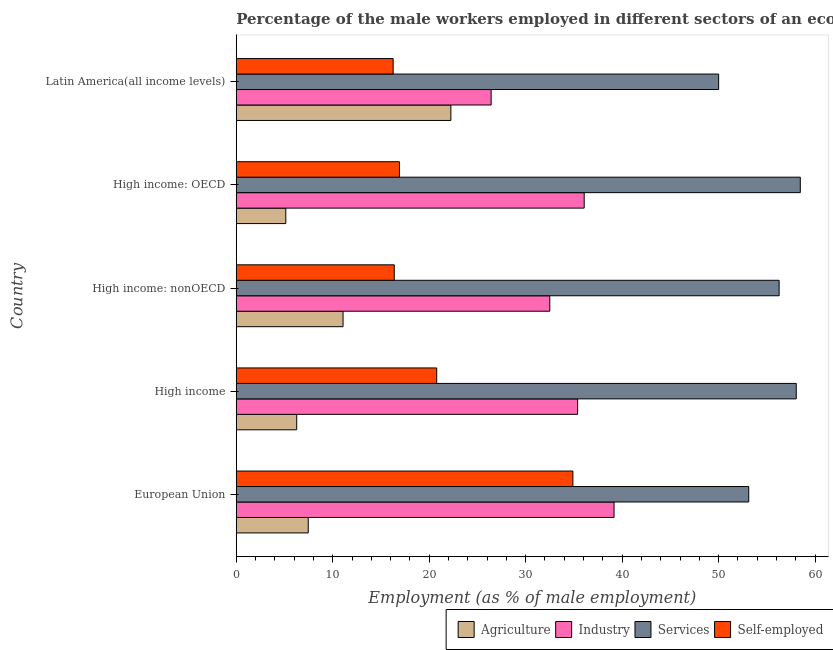How many different coloured bars are there?
Provide a succinct answer. 4. How many groups of bars are there?
Your response must be concise. 5. How many bars are there on the 1st tick from the top?
Provide a short and direct response. 4. How many bars are there on the 5th tick from the bottom?
Provide a succinct answer. 4. What is the label of the 5th group of bars from the top?
Provide a short and direct response. European Union. In how many cases, is the number of bars for a given country not equal to the number of legend labels?
Your answer should be compact. 0. What is the percentage of self employed male workers in European Union?
Provide a succinct answer. 34.89. Across all countries, what is the maximum percentage of self employed male workers?
Your answer should be very brief. 34.89. Across all countries, what is the minimum percentage of self employed male workers?
Provide a short and direct response. 16.26. In which country was the percentage of male workers in industry maximum?
Ensure brevity in your answer.  European Union. In which country was the percentage of male workers in agriculture minimum?
Your answer should be very brief. High income: OECD. What is the total percentage of self employed male workers in the graph?
Ensure brevity in your answer.  105.23. What is the difference between the percentage of self employed male workers in High income and that in High income: nonOECD?
Keep it short and to the point. 4.4. What is the difference between the percentage of male workers in services in High income and the percentage of male workers in agriculture in High income: OECD?
Your answer should be compact. 52.91. What is the average percentage of self employed male workers per country?
Ensure brevity in your answer.  21.05. What is the difference between the percentage of self employed male workers and percentage of male workers in industry in High income: nonOECD?
Your answer should be very brief. -16.12. In how many countries, is the percentage of self employed male workers greater than 50 %?
Offer a terse response. 0. What is the ratio of the percentage of male workers in services in European Union to that in High income: OECD?
Keep it short and to the point. 0.91. Is the difference between the percentage of male workers in agriculture in European Union and High income: OECD greater than the difference between the percentage of self employed male workers in European Union and High income: OECD?
Your answer should be very brief. No. What is the difference between the highest and the second highest percentage of male workers in agriculture?
Offer a terse response. 11.18. What is the difference between the highest and the lowest percentage of male workers in services?
Provide a succinct answer. 8.46. In how many countries, is the percentage of male workers in services greater than the average percentage of male workers in services taken over all countries?
Ensure brevity in your answer.  3. Is it the case that in every country, the sum of the percentage of male workers in industry and percentage of male workers in services is greater than the sum of percentage of self employed male workers and percentage of male workers in agriculture?
Offer a very short reply. Yes. What does the 2nd bar from the top in European Union represents?
Your answer should be compact. Services. What does the 1st bar from the bottom in High income: nonOECD represents?
Your answer should be very brief. Agriculture. Are all the bars in the graph horizontal?
Provide a succinct answer. Yes. Where does the legend appear in the graph?
Your answer should be very brief. Bottom right. How many legend labels are there?
Your answer should be very brief. 4. How are the legend labels stacked?
Offer a very short reply. Horizontal. What is the title of the graph?
Make the answer very short. Percentage of the male workers employed in different sectors of an economy in 2001. Does "Bird species" appear as one of the legend labels in the graph?
Offer a terse response. No. What is the label or title of the X-axis?
Keep it short and to the point. Employment (as % of male employment). What is the Employment (as % of male employment) of Agriculture in European Union?
Your response must be concise. 7.46. What is the Employment (as % of male employment) in Industry in European Union?
Make the answer very short. 39.16. What is the Employment (as % of male employment) in Services in European Union?
Provide a short and direct response. 53.12. What is the Employment (as % of male employment) in Self-employed in European Union?
Keep it short and to the point. 34.89. What is the Employment (as % of male employment) in Agriculture in High income?
Give a very brief answer. 6.27. What is the Employment (as % of male employment) in Industry in High income?
Keep it short and to the point. 35.38. What is the Employment (as % of male employment) in Services in High income?
Provide a succinct answer. 58.05. What is the Employment (as % of male employment) in Self-employed in High income?
Ensure brevity in your answer.  20.78. What is the Employment (as % of male employment) in Agriculture in High income: nonOECD?
Keep it short and to the point. 11.07. What is the Employment (as % of male employment) in Industry in High income: nonOECD?
Offer a very short reply. 32.5. What is the Employment (as % of male employment) in Services in High income: nonOECD?
Ensure brevity in your answer.  56.27. What is the Employment (as % of male employment) in Self-employed in High income: nonOECD?
Your answer should be compact. 16.38. What is the Employment (as % of male employment) in Agriculture in High income: OECD?
Your response must be concise. 5.14. What is the Employment (as % of male employment) in Industry in High income: OECD?
Make the answer very short. 36.07. What is the Employment (as % of male employment) of Services in High income: OECD?
Offer a very short reply. 58.46. What is the Employment (as % of male employment) of Self-employed in High income: OECD?
Your answer should be compact. 16.92. What is the Employment (as % of male employment) of Agriculture in Latin America(all income levels)?
Provide a succinct answer. 22.25. What is the Employment (as % of male employment) in Industry in Latin America(all income levels)?
Keep it short and to the point. 26.42. What is the Employment (as % of male employment) of Services in Latin America(all income levels)?
Offer a very short reply. 50. What is the Employment (as % of male employment) of Self-employed in Latin America(all income levels)?
Give a very brief answer. 16.26. Across all countries, what is the maximum Employment (as % of male employment) of Agriculture?
Offer a terse response. 22.25. Across all countries, what is the maximum Employment (as % of male employment) of Industry?
Provide a succinct answer. 39.16. Across all countries, what is the maximum Employment (as % of male employment) in Services?
Ensure brevity in your answer.  58.46. Across all countries, what is the maximum Employment (as % of male employment) of Self-employed?
Your answer should be very brief. 34.89. Across all countries, what is the minimum Employment (as % of male employment) of Agriculture?
Make the answer very short. 5.14. Across all countries, what is the minimum Employment (as % of male employment) of Industry?
Offer a terse response. 26.42. Across all countries, what is the minimum Employment (as % of male employment) of Services?
Provide a succinct answer. 50. Across all countries, what is the minimum Employment (as % of male employment) of Self-employed?
Offer a very short reply. 16.26. What is the total Employment (as % of male employment) of Agriculture in the graph?
Provide a succinct answer. 52.18. What is the total Employment (as % of male employment) of Industry in the graph?
Provide a succinct answer. 169.53. What is the total Employment (as % of male employment) of Services in the graph?
Ensure brevity in your answer.  275.9. What is the total Employment (as % of male employment) in Self-employed in the graph?
Keep it short and to the point. 105.23. What is the difference between the Employment (as % of male employment) of Agriculture in European Union and that in High income?
Make the answer very short. 1.2. What is the difference between the Employment (as % of male employment) in Industry in European Union and that in High income?
Your response must be concise. 3.78. What is the difference between the Employment (as % of male employment) in Services in European Union and that in High income?
Offer a terse response. -4.92. What is the difference between the Employment (as % of male employment) in Self-employed in European Union and that in High income?
Provide a succinct answer. 14.11. What is the difference between the Employment (as % of male employment) in Agriculture in European Union and that in High income: nonOECD?
Offer a very short reply. -3.61. What is the difference between the Employment (as % of male employment) of Industry in European Union and that in High income: nonOECD?
Provide a succinct answer. 6.66. What is the difference between the Employment (as % of male employment) of Services in European Union and that in High income: nonOECD?
Offer a terse response. -3.15. What is the difference between the Employment (as % of male employment) of Self-employed in European Union and that in High income: nonOECD?
Your answer should be compact. 18.51. What is the difference between the Employment (as % of male employment) of Agriculture in European Union and that in High income: OECD?
Your answer should be compact. 2.33. What is the difference between the Employment (as % of male employment) of Industry in European Union and that in High income: OECD?
Your response must be concise. 3.1. What is the difference between the Employment (as % of male employment) of Services in European Union and that in High income: OECD?
Keep it short and to the point. -5.34. What is the difference between the Employment (as % of male employment) of Self-employed in European Union and that in High income: OECD?
Provide a short and direct response. 17.98. What is the difference between the Employment (as % of male employment) in Agriculture in European Union and that in Latin America(all income levels)?
Provide a short and direct response. -14.78. What is the difference between the Employment (as % of male employment) in Industry in European Union and that in Latin America(all income levels)?
Keep it short and to the point. 12.74. What is the difference between the Employment (as % of male employment) of Services in European Union and that in Latin America(all income levels)?
Provide a succinct answer. 3.12. What is the difference between the Employment (as % of male employment) of Self-employed in European Union and that in Latin America(all income levels)?
Provide a short and direct response. 18.63. What is the difference between the Employment (as % of male employment) in Agriculture in High income and that in High income: nonOECD?
Give a very brief answer. -4.8. What is the difference between the Employment (as % of male employment) in Industry in High income and that in High income: nonOECD?
Keep it short and to the point. 2.89. What is the difference between the Employment (as % of male employment) of Services in High income and that in High income: nonOECD?
Offer a terse response. 1.78. What is the difference between the Employment (as % of male employment) of Self-employed in High income and that in High income: nonOECD?
Offer a very short reply. 4.4. What is the difference between the Employment (as % of male employment) of Agriculture in High income and that in High income: OECD?
Provide a succinct answer. 1.13. What is the difference between the Employment (as % of male employment) in Industry in High income and that in High income: OECD?
Ensure brevity in your answer.  -0.68. What is the difference between the Employment (as % of male employment) in Services in High income and that in High income: OECD?
Keep it short and to the point. -0.42. What is the difference between the Employment (as % of male employment) of Self-employed in High income and that in High income: OECD?
Your answer should be very brief. 3.86. What is the difference between the Employment (as % of male employment) in Agriculture in High income and that in Latin America(all income levels)?
Ensure brevity in your answer.  -15.98. What is the difference between the Employment (as % of male employment) in Industry in High income and that in Latin America(all income levels)?
Your answer should be compact. 8.97. What is the difference between the Employment (as % of male employment) in Services in High income and that in Latin America(all income levels)?
Provide a succinct answer. 8.04. What is the difference between the Employment (as % of male employment) of Self-employed in High income and that in Latin America(all income levels)?
Your response must be concise. 4.51. What is the difference between the Employment (as % of male employment) in Agriculture in High income: nonOECD and that in High income: OECD?
Provide a succinct answer. 5.93. What is the difference between the Employment (as % of male employment) in Industry in High income: nonOECD and that in High income: OECD?
Provide a succinct answer. -3.57. What is the difference between the Employment (as % of male employment) of Services in High income: nonOECD and that in High income: OECD?
Your answer should be very brief. -2.19. What is the difference between the Employment (as % of male employment) in Self-employed in High income: nonOECD and that in High income: OECD?
Provide a short and direct response. -0.54. What is the difference between the Employment (as % of male employment) of Agriculture in High income: nonOECD and that in Latin America(all income levels)?
Offer a terse response. -11.18. What is the difference between the Employment (as % of male employment) in Industry in High income: nonOECD and that in Latin America(all income levels)?
Provide a short and direct response. 6.08. What is the difference between the Employment (as % of male employment) of Services in High income: nonOECD and that in Latin America(all income levels)?
Provide a short and direct response. 6.27. What is the difference between the Employment (as % of male employment) in Self-employed in High income: nonOECD and that in Latin America(all income levels)?
Offer a very short reply. 0.11. What is the difference between the Employment (as % of male employment) of Agriculture in High income: OECD and that in Latin America(all income levels)?
Provide a succinct answer. -17.11. What is the difference between the Employment (as % of male employment) in Industry in High income: OECD and that in Latin America(all income levels)?
Your response must be concise. 9.65. What is the difference between the Employment (as % of male employment) of Services in High income: OECD and that in Latin America(all income levels)?
Provide a succinct answer. 8.46. What is the difference between the Employment (as % of male employment) in Self-employed in High income: OECD and that in Latin America(all income levels)?
Ensure brevity in your answer.  0.65. What is the difference between the Employment (as % of male employment) in Agriculture in European Union and the Employment (as % of male employment) in Industry in High income?
Your answer should be very brief. -27.92. What is the difference between the Employment (as % of male employment) in Agriculture in European Union and the Employment (as % of male employment) in Services in High income?
Offer a terse response. -50.58. What is the difference between the Employment (as % of male employment) in Agriculture in European Union and the Employment (as % of male employment) in Self-employed in High income?
Ensure brevity in your answer.  -13.31. What is the difference between the Employment (as % of male employment) in Industry in European Union and the Employment (as % of male employment) in Services in High income?
Your answer should be compact. -18.88. What is the difference between the Employment (as % of male employment) of Industry in European Union and the Employment (as % of male employment) of Self-employed in High income?
Offer a very short reply. 18.38. What is the difference between the Employment (as % of male employment) in Services in European Union and the Employment (as % of male employment) in Self-employed in High income?
Provide a short and direct response. 32.34. What is the difference between the Employment (as % of male employment) of Agriculture in European Union and the Employment (as % of male employment) of Industry in High income: nonOECD?
Offer a terse response. -25.04. What is the difference between the Employment (as % of male employment) in Agriculture in European Union and the Employment (as % of male employment) in Services in High income: nonOECD?
Your answer should be compact. -48.81. What is the difference between the Employment (as % of male employment) of Agriculture in European Union and the Employment (as % of male employment) of Self-employed in High income: nonOECD?
Your response must be concise. -8.92. What is the difference between the Employment (as % of male employment) in Industry in European Union and the Employment (as % of male employment) in Services in High income: nonOECD?
Offer a very short reply. -17.11. What is the difference between the Employment (as % of male employment) of Industry in European Union and the Employment (as % of male employment) of Self-employed in High income: nonOECD?
Your answer should be very brief. 22.78. What is the difference between the Employment (as % of male employment) of Services in European Union and the Employment (as % of male employment) of Self-employed in High income: nonOECD?
Provide a succinct answer. 36.74. What is the difference between the Employment (as % of male employment) in Agriculture in European Union and the Employment (as % of male employment) in Industry in High income: OECD?
Ensure brevity in your answer.  -28.6. What is the difference between the Employment (as % of male employment) of Agriculture in European Union and the Employment (as % of male employment) of Services in High income: OECD?
Offer a very short reply. -51. What is the difference between the Employment (as % of male employment) in Agriculture in European Union and the Employment (as % of male employment) in Self-employed in High income: OECD?
Ensure brevity in your answer.  -9.45. What is the difference between the Employment (as % of male employment) in Industry in European Union and the Employment (as % of male employment) in Services in High income: OECD?
Your answer should be very brief. -19.3. What is the difference between the Employment (as % of male employment) of Industry in European Union and the Employment (as % of male employment) of Self-employed in High income: OECD?
Provide a short and direct response. 22.24. What is the difference between the Employment (as % of male employment) of Services in European Union and the Employment (as % of male employment) of Self-employed in High income: OECD?
Ensure brevity in your answer.  36.2. What is the difference between the Employment (as % of male employment) in Agriculture in European Union and the Employment (as % of male employment) in Industry in Latin America(all income levels)?
Your answer should be very brief. -18.96. What is the difference between the Employment (as % of male employment) of Agriculture in European Union and the Employment (as % of male employment) of Services in Latin America(all income levels)?
Your answer should be very brief. -42.54. What is the difference between the Employment (as % of male employment) of Agriculture in European Union and the Employment (as % of male employment) of Self-employed in Latin America(all income levels)?
Your answer should be very brief. -8.8. What is the difference between the Employment (as % of male employment) of Industry in European Union and the Employment (as % of male employment) of Services in Latin America(all income levels)?
Offer a very short reply. -10.84. What is the difference between the Employment (as % of male employment) of Industry in European Union and the Employment (as % of male employment) of Self-employed in Latin America(all income levels)?
Offer a very short reply. 22.9. What is the difference between the Employment (as % of male employment) of Services in European Union and the Employment (as % of male employment) of Self-employed in Latin America(all income levels)?
Provide a succinct answer. 36.86. What is the difference between the Employment (as % of male employment) in Agriculture in High income and the Employment (as % of male employment) in Industry in High income: nonOECD?
Keep it short and to the point. -26.23. What is the difference between the Employment (as % of male employment) in Agriculture in High income and the Employment (as % of male employment) in Services in High income: nonOECD?
Keep it short and to the point. -50. What is the difference between the Employment (as % of male employment) in Agriculture in High income and the Employment (as % of male employment) in Self-employed in High income: nonOECD?
Offer a terse response. -10.11. What is the difference between the Employment (as % of male employment) of Industry in High income and the Employment (as % of male employment) of Services in High income: nonOECD?
Your answer should be very brief. -20.89. What is the difference between the Employment (as % of male employment) in Industry in High income and the Employment (as % of male employment) in Self-employed in High income: nonOECD?
Provide a short and direct response. 19.01. What is the difference between the Employment (as % of male employment) in Services in High income and the Employment (as % of male employment) in Self-employed in High income: nonOECD?
Your answer should be very brief. 41.67. What is the difference between the Employment (as % of male employment) of Agriculture in High income and the Employment (as % of male employment) of Industry in High income: OECD?
Your response must be concise. -29.8. What is the difference between the Employment (as % of male employment) in Agriculture in High income and the Employment (as % of male employment) in Services in High income: OECD?
Keep it short and to the point. -52.2. What is the difference between the Employment (as % of male employment) of Agriculture in High income and the Employment (as % of male employment) of Self-employed in High income: OECD?
Give a very brief answer. -10.65. What is the difference between the Employment (as % of male employment) in Industry in High income and the Employment (as % of male employment) in Services in High income: OECD?
Provide a succinct answer. -23.08. What is the difference between the Employment (as % of male employment) in Industry in High income and the Employment (as % of male employment) in Self-employed in High income: OECD?
Keep it short and to the point. 18.47. What is the difference between the Employment (as % of male employment) of Services in High income and the Employment (as % of male employment) of Self-employed in High income: OECD?
Your answer should be compact. 41.13. What is the difference between the Employment (as % of male employment) in Agriculture in High income and the Employment (as % of male employment) in Industry in Latin America(all income levels)?
Make the answer very short. -20.15. What is the difference between the Employment (as % of male employment) in Agriculture in High income and the Employment (as % of male employment) in Services in Latin America(all income levels)?
Your response must be concise. -43.73. What is the difference between the Employment (as % of male employment) in Agriculture in High income and the Employment (as % of male employment) in Self-employed in Latin America(all income levels)?
Keep it short and to the point. -10. What is the difference between the Employment (as % of male employment) in Industry in High income and the Employment (as % of male employment) in Services in Latin America(all income levels)?
Ensure brevity in your answer.  -14.62. What is the difference between the Employment (as % of male employment) in Industry in High income and the Employment (as % of male employment) in Self-employed in Latin America(all income levels)?
Make the answer very short. 19.12. What is the difference between the Employment (as % of male employment) of Services in High income and the Employment (as % of male employment) of Self-employed in Latin America(all income levels)?
Your response must be concise. 41.78. What is the difference between the Employment (as % of male employment) of Agriculture in High income: nonOECD and the Employment (as % of male employment) of Industry in High income: OECD?
Ensure brevity in your answer.  -25. What is the difference between the Employment (as % of male employment) in Agriculture in High income: nonOECD and the Employment (as % of male employment) in Services in High income: OECD?
Your answer should be compact. -47.39. What is the difference between the Employment (as % of male employment) of Agriculture in High income: nonOECD and the Employment (as % of male employment) of Self-employed in High income: OECD?
Give a very brief answer. -5.85. What is the difference between the Employment (as % of male employment) in Industry in High income: nonOECD and the Employment (as % of male employment) in Services in High income: OECD?
Provide a succinct answer. -25.97. What is the difference between the Employment (as % of male employment) in Industry in High income: nonOECD and the Employment (as % of male employment) in Self-employed in High income: OECD?
Offer a terse response. 15.58. What is the difference between the Employment (as % of male employment) of Services in High income: nonOECD and the Employment (as % of male employment) of Self-employed in High income: OECD?
Keep it short and to the point. 39.35. What is the difference between the Employment (as % of male employment) in Agriculture in High income: nonOECD and the Employment (as % of male employment) in Industry in Latin America(all income levels)?
Your answer should be very brief. -15.35. What is the difference between the Employment (as % of male employment) in Agriculture in High income: nonOECD and the Employment (as % of male employment) in Services in Latin America(all income levels)?
Your answer should be compact. -38.93. What is the difference between the Employment (as % of male employment) of Agriculture in High income: nonOECD and the Employment (as % of male employment) of Self-employed in Latin America(all income levels)?
Provide a short and direct response. -5.19. What is the difference between the Employment (as % of male employment) in Industry in High income: nonOECD and the Employment (as % of male employment) in Services in Latin America(all income levels)?
Provide a succinct answer. -17.5. What is the difference between the Employment (as % of male employment) of Industry in High income: nonOECD and the Employment (as % of male employment) of Self-employed in Latin America(all income levels)?
Offer a terse response. 16.23. What is the difference between the Employment (as % of male employment) in Services in High income: nonOECD and the Employment (as % of male employment) in Self-employed in Latin America(all income levels)?
Your response must be concise. 40.01. What is the difference between the Employment (as % of male employment) of Agriculture in High income: OECD and the Employment (as % of male employment) of Industry in Latin America(all income levels)?
Your response must be concise. -21.28. What is the difference between the Employment (as % of male employment) of Agriculture in High income: OECD and the Employment (as % of male employment) of Services in Latin America(all income levels)?
Keep it short and to the point. -44.87. What is the difference between the Employment (as % of male employment) in Agriculture in High income: OECD and the Employment (as % of male employment) in Self-employed in Latin America(all income levels)?
Offer a very short reply. -11.13. What is the difference between the Employment (as % of male employment) in Industry in High income: OECD and the Employment (as % of male employment) in Services in Latin America(all income levels)?
Make the answer very short. -13.94. What is the difference between the Employment (as % of male employment) in Industry in High income: OECD and the Employment (as % of male employment) in Self-employed in Latin America(all income levels)?
Ensure brevity in your answer.  19.8. What is the difference between the Employment (as % of male employment) of Services in High income: OECD and the Employment (as % of male employment) of Self-employed in Latin America(all income levels)?
Your answer should be very brief. 42.2. What is the average Employment (as % of male employment) of Agriculture per country?
Your answer should be compact. 10.44. What is the average Employment (as % of male employment) in Industry per country?
Keep it short and to the point. 33.91. What is the average Employment (as % of male employment) of Services per country?
Your response must be concise. 55.18. What is the average Employment (as % of male employment) in Self-employed per country?
Offer a terse response. 21.05. What is the difference between the Employment (as % of male employment) in Agriculture and Employment (as % of male employment) in Industry in European Union?
Your answer should be very brief. -31.7. What is the difference between the Employment (as % of male employment) in Agriculture and Employment (as % of male employment) in Services in European Union?
Ensure brevity in your answer.  -45.66. What is the difference between the Employment (as % of male employment) of Agriculture and Employment (as % of male employment) of Self-employed in European Union?
Keep it short and to the point. -27.43. What is the difference between the Employment (as % of male employment) of Industry and Employment (as % of male employment) of Services in European Union?
Offer a terse response. -13.96. What is the difference between the Employment (as % of male employment) of Industry and Employment (as % of male employment) of Self-employed in European Union?
Make the answer very short. 4.27. What is the difference between the Employment (as % of male employment) of Services and Employment (as % of male employment) of Self-employed in European Union?
Give a very brief answer. 18.23. What is the difference between the Employment (as % of male employment) of Agriculture and Employment (as % of male employment) of Industry in High income?
Provide a succinct answer. -29.12. What is the difference between the Employment (as % of male employment) in Agriculture and Employment (as % of male employment) in Services in High income?
Provide a short and direct response. -51.78. What is the difference between the Employment (as % of male employment) in Agriculture and Employment (as % of male employment) in Self-employed in High income?
Your answer should be compact. -14.51. What is the difference between the Employment (as % of male employment) of Industry and Employment (as % of male employment) of Services in High income?
Offer a very short reply. -22.66. What is the difference between the Employment (as % of male employment) of Industry and Employment (as % of male employment) of Self-employed in High income?
Make the answer very short. 14.61. What is the difference between the Employment (as % of male employment) in Services and Employment (as % of male employment) in Self-employed in High income?
Keep it short and to the point. 37.27. What is the difference between the Employment (as % of male employment) of Agriculture and Employment (as % of male employment) of Industry in High income: nonOECD?
Ensure brevity in your answer.  -21.43. What is the difference between the Employment (as % of male employment) of Agriculture and Employment (as % of male employment) of Services in High income: nonOECD?
Keep it short and to the point. -45.2. What is the difference between the Employment (as % of male employment) of Agriculture and Employment (as % of male employment) of Self-employed in High income: nonOECD?
Offer a very short reply. -5.31. What is the difference between the Employment (as % of male employment) in Industry and Employment (as % of male employment) in Services in High income: nonOECD?
Offer a terse response. -23.77. What is the difference between the Employment (as % of male employment) of Industry and Employment (as % of male employment) of Self-employed in High income: nonOECD?
Offer a very short reply. 16.12. What is the difference between the Employment (as % of male employment) in Services and Employment (as % of male employment) in Self-employed in High income: nonOECD?
Keep it short and to the point. 39.89. What is the difference between the Employment (as % of male employment) of Agriculture and Employment (as % of male employment) of Industry in High income: OECD?
Your answer should be compact. -30.93. What is the difference between the Employment (as % of male employment) in Agriculture and Employment (as % of male employment) in Services in High income: OECD?
Make the answer very short. -53.33. What is the difference between the Employment (as % of male employment) in Agriculture and Employment (as % of male employment) in Self-employed in High income: OECD?
Your answer should be compact. -11.78. What is the difference between the Employment (as % of male employment) in Industry and Employment (as % of male employment) in Services in High income: OECD?
Keep it short and to the point. -22.4. What is the difference between the Employment (as % of male employment) of Industry and Employment (as % of male employment) of Self-employed in High income: OECD?
Give a very brief answer. 19.15. What is the difference between the Employment (as % of male employment) in Services and Employment (as % of male employment) in Self-employed in High income: OECD?
Make the answer very short. 41.55. What is the difference between the Employment (as % of male employment) in Agriculture and Employment (as % of male employment) in Industry in Latin America(all income levels)?
Offer a terse response. -4.17. What is the difference between the Employment (as % of male employment) in Agriculture and Employment (as % of male employment) in Services in Latin America(all income levels)?
Ensure brevity in your answer.  -27.75. What is the difference between the Employment (as % of male employment) in Agriculture and Employment (as % of male employment) in Self-employed in Latin America(all income levels)?
Your answer should be compact. 5.98. What is the difference between the Employment (as % of male employment) of Industry and Employment (as % of male employment) of Services in Latin America(all income levels)?
Your answer should be very brief. -23.58. What is the difference between the Employment (as % of male employment) in Industry and Employment (as % of male employment) in Self-employed in Latin America(all income levels)?
Your response must be concise. 10.15. What is the difference between the Employment (as % of male employment) in Services and Employment (as % of male employment) in Self-employed in Latin America(all income levels)?
Ensure brevity in your answer.  33.74. What is the ratio of the Employment (as % of male employment) of Agriculture in European Union to that in High income?
Your answer should be compact. 1.19. What is the ratio of the Employment (as % of male employment) in Industry in European Union to that in High income?
Provide a short and direct response. 1.11. What is the ratio of the Employment (as % of male employment) of Services in European Union to that in High income?
Provide a short and direct response. 0.92. What is the ratio of the Employment (as % of male employment) of Self-employed in European Union to that in High income?
Keep it short and to the point. 1.68. What is the ratio of the Employment (as % of male employment) in Agriculture in European Union to that in High income: nonOECD?
Offer a terse response. 0.67. What is the ratio of the Employment (as % of male employment) of Industry in European Union to that in High income: nonOECD?
Offer a terse response. 1.21. What is the ratio of the Employment (as % of male employment) in Services in European Union to that in High income: nonOECD?
Offer a very short reply. 0.94. What is the ratio of the Employment (as % of male employment) of Self-employed in European Union to that in High income: nonOECD?
Offer a terse response. 2.13. What is the ratio of the Employment (as % of male employment) of Agriculture in European Union to that in High income: OECD?
Make the answer very short. 1.45. What is the ratio of the Employment (as % of male employment) in Industry in European Union to that in High income: OECD?
Your answer should be very brief. 1.09. What is the ratio of the Employment (as % of male employment) in Services in European Union to that in High income: OECD?
Offer a very short reply. 0.91. What is the ratio of the Employment (as % of male employment) in Self-employed in European Union to that in High income: OECD?
Give a very brief answer. 2.06. What is the ratio of the Employment (as % of male employment) in Agriculture in European Union to that in Latin America(all income levels)?
Offer a very short reply. 0.34. What is the ratio of the Employment (as % of male employment) of Industry in European Union to that in Latin America(all income levels)?
Offer a terse response. 1.48. What is the ratio of the Employment (as % of male employment) of Services in European Union to that in Latin America(all income levels)?
Offer a terse response. 1.06. What is the ratio of the Employment (as % of male employment) of Self-employed in European Union to that in Latin America(all income levels)?
Give a very brief answer. 2.15. What is the ratio of the Employment (as % of male employment) in Agriculture in High income to that in High income: nonOECD?
Your response must be concise. 0.57. What is the ratio of the Employment (as % of male employment) in Industry in High income to that in High income: nonOECD?
Offer a terse response. 1.09. What is the ratio of the Employment (as % of male employment) of Services in High income to that in High income: nonOECD?
Provide a succinct answer. 1.03. What is the ratio of the Employment (as % of male employment) of Self-employed in High income to that in High income: nonOECD?
Keep it short and to the point. 1.27. What is the ratio of the Employment (as % of male employment) of Agriculture in High income to that in High income: OECD?
Offer a terse response. 1.22. What is the ratio of the Employment (as % of male employment) in Industry in High income to that in High income: OECD?
Give a very brief answer. 0.98. What is the ratio of the Employment (as % of male employment) in Services in High income to that in High income: OECD?
Make the answer very short. 0.99. What is the ratio of the Employment (as % of male employment) of Self-employed in High income to that in High income: OECD?
Offer a very short reply. 1.23. What is the ratio of the Employment (as % of male employment) of Agriculture in High income to that in Latin America(all income levels)?
Your answer should be compact. 0.28. What is the ratio of the Employment (as % of male employment) of Industry in High income to that in Latin America(all income levels)?
Your answer should be very brief. 1.34. What is the ratio of the Employment (as % of male employment) of Services in High income to that in Latin America(all income levels)?
Provide a succinct answer. 1.16. What is the ratio of the Employment (as % of male employment) in Self-employed in High income to that in Latin America(all income levels)?
Ensure brevity in your answer.  1.28. What is the ratio of the Employment (as % of male employment) of Agriculture in High income: nonOECD to that in High income: OECD?
Ensure brevity in your answer.  2.16. What is the ratio of the Employment (as % of male employment) in Industry in High income: nonOECD to that in High income: OECD?
Offer a very short reply. 0.9. What is the ratio of the Employment (as % of male employment) of Services in High income: nonOECD to that in High income: OECD?
Make the answer very short. 0.96. What is the ratio of the Employment (as % of male employment) of Self-employed in High income: nonOECD to that in High income: OECD?
Your answer should be compact. 0.97. What is the ratio of the Employment (as % of male employment) in Agriculture in High income: nonOECD to that in Latin America(all income levels)?
Keep it short and to the point. 0.5. What is the ratio of the Employment (as % of male employment) of Industry in High income: nonOECD to that in Latin America(all income levels)?
Offer a terse response. 1.23. What is the ratio of the Employment (as % of male employment) in Services in High income: nonOECD to that in Latin America(all income levels)?
Keep it short and to the point. 1.13. What is the ratio of the Employment (as % of male employment) of Self-employed in High income: nonOECD to that in Latin America(all income levels)?
Offer a terse response. 1.01. What is the ratio of the Employment (as % of male employment) of Agriculture in High income: OECD to that in Latin America(all income levels)?
Provide a succinct answer. 0.23. What is the ratio of the Employment (as % of male employment) in Industry in High income: OECD to that in Latin America(all income levels)?
Offer a terse response. 1.37. What is the ratio of the Employment (as % of male employment) in Services in High income: OECD to that in Latin America(all income levels)?
Ensure brevity in your answer.  1.17. What is the ratio of the Employment (as % of male employment) in Self-employed in High income: OECD to that in Latin America(all income levels)?
Offer a terse response. 1.04. What is the difference between the highest and the second highest Employment (as % of male employment) of Agriculture?
Make the answer very short. 11.18. What is the difference between the highest and the second highest Employment (as % of male employment) of Industry?
Your answer should be compact. 3.1. What is the difference between the highest and the second highest Employment (as % of male employment) of Services?
Make the answer very short. 0.42. What is the difference between the highest and the second highest Employment (as % of male employment) in Self-employed?
Your answer should be compact. 14.11. What is the difference between the highest and the lowest Employment (as % of male employment) of Agriculture?
Make the answer very short. 17.11. What is the difference between the highest and the lowest Employment (as % of male employment) in Industry?
Your answer should be very brief. 12.74. What is the difference between the highest and the lowest Employment (as % of male employment) of Services?
Give a very brief answer. 8.46. What is the difference between the highest and the lowest Employment (as % of male employment) in Self-employed?
Your answer should be compact. 18.63. 